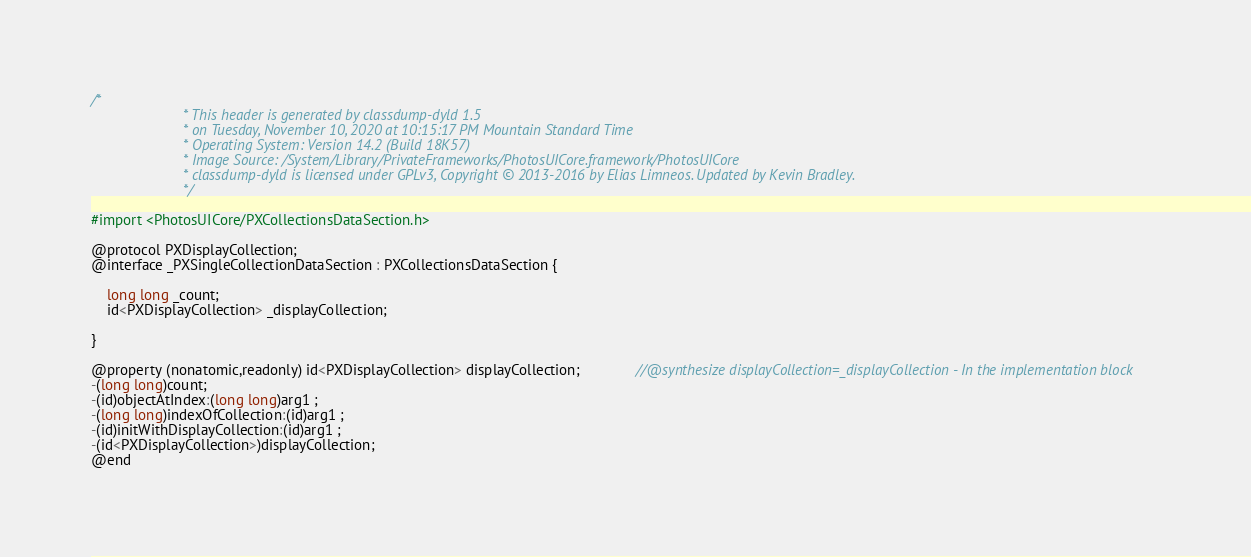<code> <loc_0><loc_0><loc_500><loc_500><_C_>/*
                       * This header is generated by classdump-dyld 1.5
                       * on Tuesday, November 10, 2020 at 10:15:17 PM Mountain Standard Time
                       * Operating System: Version 14.2 (Build 18K57)
                       * Image Source: /System/Library/PrivateFrameworks/PhotosUICore.framework/PhotosUICore
                       * classdump-dyld is licensed under GPLv3, Copyright © 2013-2016 by Elias Limneos. Updated by Kevin Bradley.
                       */

#import <PhotosUICore/PXCollectionsDataSection.h>

@protocol PXDisplayCollection;
@interface _PXSingleCollectionDataSection : PXCollectionsDataSection {

	long long _count;
	id<PXDisplayCollection> _displayCollection;

}

@property (nonatomic,readonly) id<PXDisplayCollection> displayCollection;              //@synthesize displayCollection=_displayCollection - In the implementation block
-(long long)count;
-(id)objectAtIndex:(long long)arg1 ;
-(long long)indexOfCollection:(id)arg1 ;
-(id)initWithDisplayCollection:(id)arg1 ;
-(id<PXDisplayCollection>)displayCollection;
@end

</code> 